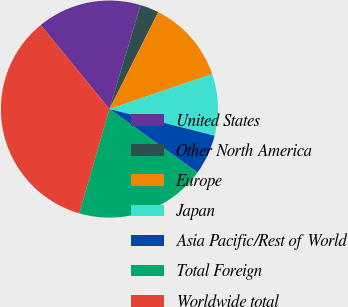<chart> <loc_0><loc_0><loc_500><loc_500><pie_chart><fcel>United States<fcel>Other North America<fcel>Europe<fcel>Japan<fcel>Asia Pacific/Rest of World<fcel>Total Foreign<fcel>Worldwide total<nl><fcel>15.53%<fcel>2.81%<fcel>12.35%<fcel>9.17%<fcel>5.99%<fcel>19.55%<fcel>34.61%<nl></chart> 